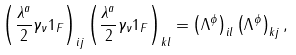<formula> <loc_0><loc_0><loc_500><loc_500>\left ( \frac { \lambda ^ { a } } { 2 } \gamma _ { \nu } { 1 } _ { F } \right ) _ { i j } \left ( \frac { \lambda ^ { a } } { 2 } \gamma _ { \nu } { 1 } _ { F } \right ) _ { k l } = \left ( \Lambda ^ { \phi } \right ) _ { i l } \left ( \Lambda ^ { \phi } \right ) _ { k j } ,</formula> 